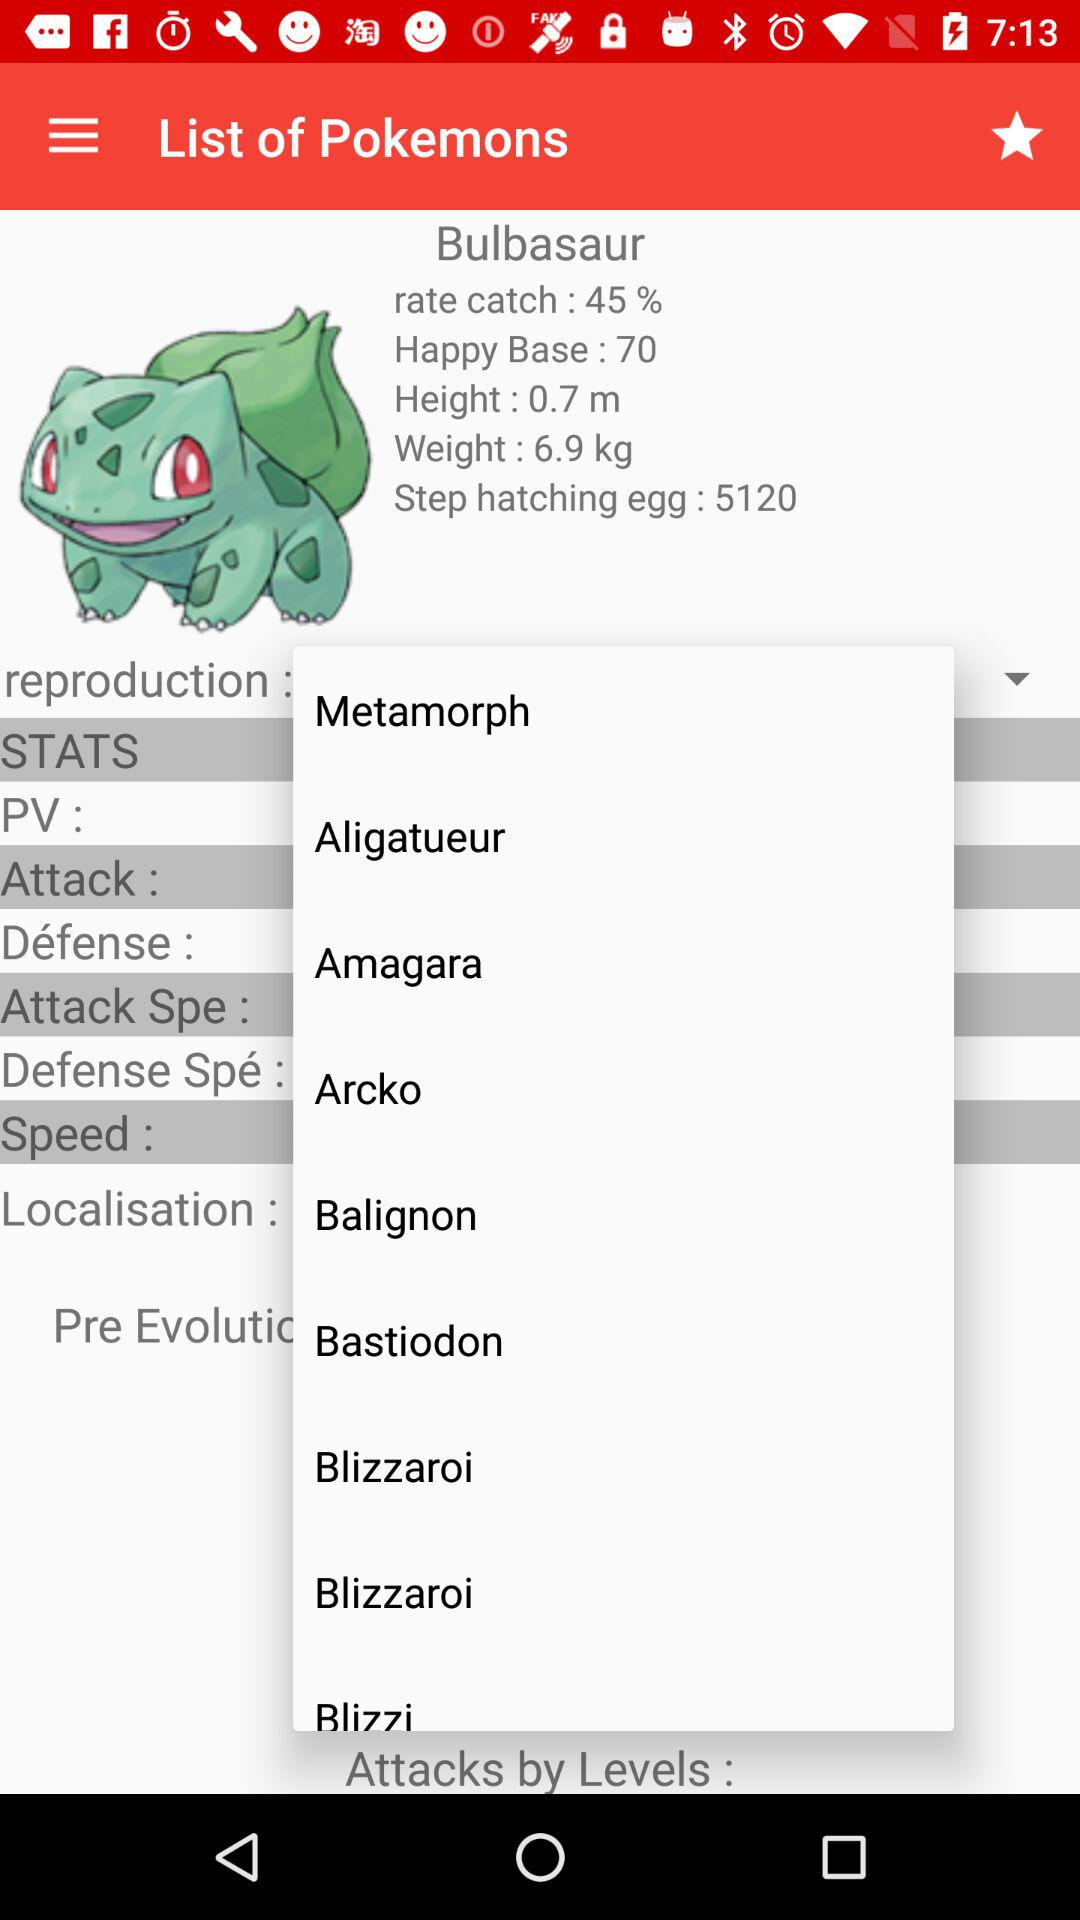What is the percentage of "rate catch"? The percentage is 45%. 